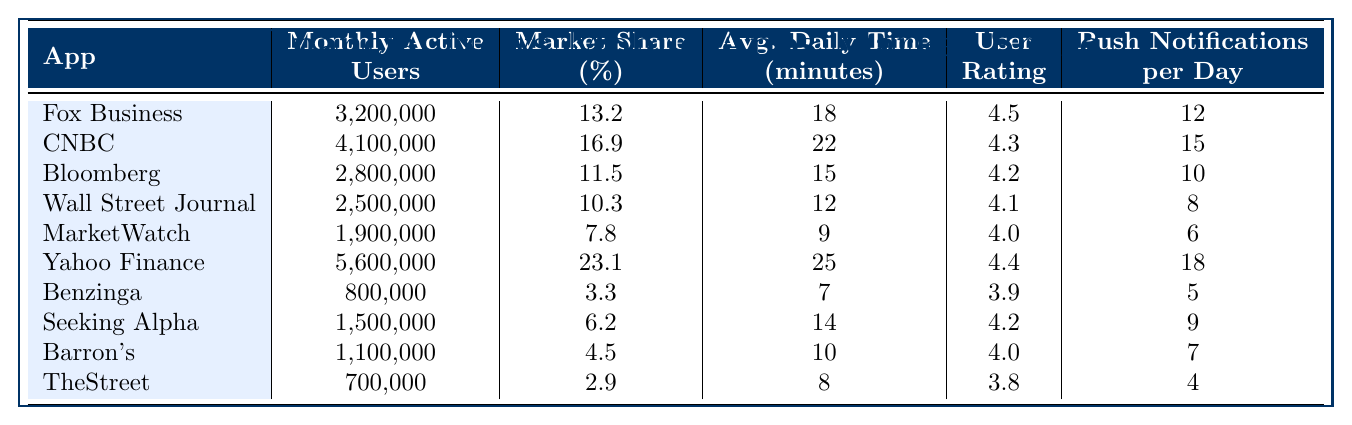What is the market share percentage of Yahoo Finance? According to the table, Yahoo Finance has a market share of 23.1 percent.
Answer: 23.1 Which app has the highest number of monthly active users? The table shows that Yahoo Finance has the highest number of monthly active users at 5,600,000.
Answer: Yahoo Finance What is the average daily time spent on Fox Business? The table indicates that users spend an average of 18 minutes per day on Fox Business.
Answer: 18 How many push notifications does CNBC send per day? According to the table, CNBC sends 15 push notifications per day.
Answer: 15 What is the total number of monthly active users for the top three apps? Adding the monthly active users for the top three apps: Yahoo Finance (5,600,000) + CNBC (4,100,000) + Fox Business (3,200,000) gives a total of 12,900,000 monthly active users.
Answer: 12,900,000 Is the average daily time spent on MarketWatch greater than that on Barron's? The average daily time spent on MarketWatch is 9 minutes, while Barron's is 10 minutes. Since 9 is less than 10, the statement is false.
Answer: No Calculate the difference in market share between Yahoo Finance and Bloomberg. Yahoo Finance has a market share of 23.1 percent, and Bloomberg has 11.5 percent. The difference is 23.1 - 11.5 = 11.6 percent.
Answer: 11.6 Which app has the lowest user rating? The table shows that TheStreet has the lowest user rating at 3.8.
Answer: TheStreet What is the average user rating of the top five financial news mobile apps? The user ratings for the top five apps are: 4.5 (Fox Business), 4.3 (CNBC), 4.2 (Bloomberg), 4.1 (Wall Street Journal), and 4.0 (MarketWatch). The total is 4.5 + 4.3 + 4.2 + 4.1 + 4.0 = 21.1, and the average is 21.1/5 = 4.22.
Answer: 4.22 Which app sends the fewest push notifications per day? The table indicates that TheStreet sends the fewest push notifications, at only 4 per day.
Answer: TheStreet 